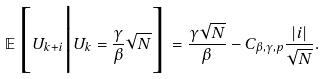<formula> <loc_0><loc_0><loc_500><loc_500>\mathbb { E } \Big [ U _ { k + i } \Big | U _ { k } = \frac { \gamma } { \beta } \sqrt { N } \Big ] = \frac { \gamma \sqrt { N } } { \beta } - C _ { \beta , \gamma , p } \frac { | i | } { \sqrt { N } } .</formula> 